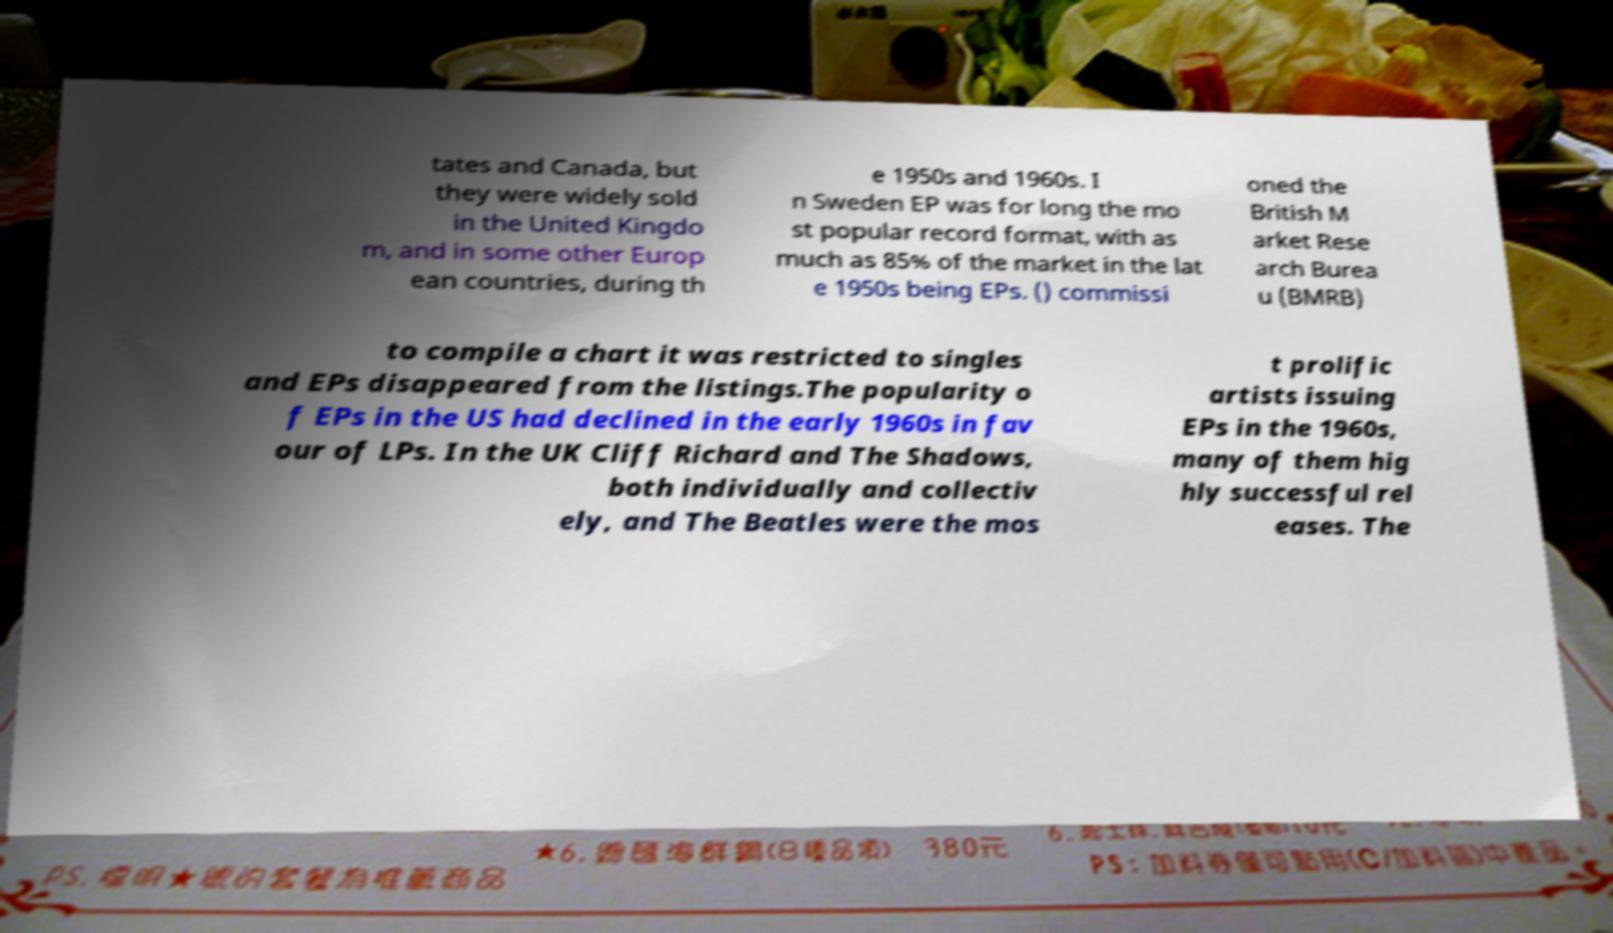Can you read and provide the text displayed in the image?This photo seems to have some interesting text. Can you extract and type it out for me? tates and Canada, but they were widely sold in the United Kingdo m, and in some other Europ ean countries, during th e 1950s and 1960s. I n Sweden EP was for long the mo st popular record format, with as much as 85% of the market in the lat e 1950s being EPs. () commissi oned the British M arket Rese arch Burea u (BMRB) to compile a chart it was restricted to singles and EPs disappeared from the listings.The popularity o f EPs in the US had declined in the early 1960s in fav our of LPs. In the UK Cliff Richard and The Shadows, both individually and collectiv ely, and The Beatles were the mos t prolific artists issuing EPs in the 1960s, many of them hig hly successful rel eases. The 